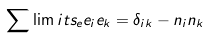Convert formula to latex. <formula><loc_0><loc_0><loc_500><loc_500>\sum \lim i t s _ { e } e _ { i } e _ { k } = \delta _ { i k } - n _ { i } n _ { k }</formula> 